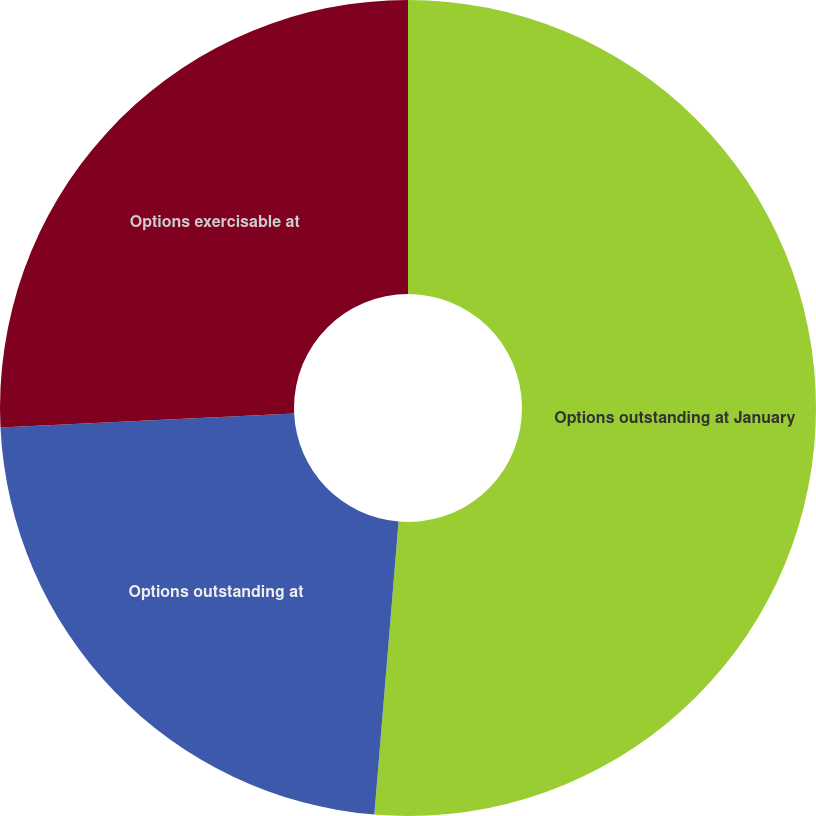<chart> <loc_0><loc_0><loc_500><loc_500><pie_chart><fcel>Options outstanding at January<fcel>Options outstanding at<fcel>Options exercisable at<nl><fcel>51.31%<fcel>22.92%<fcel>25.76%<nl></chart> 